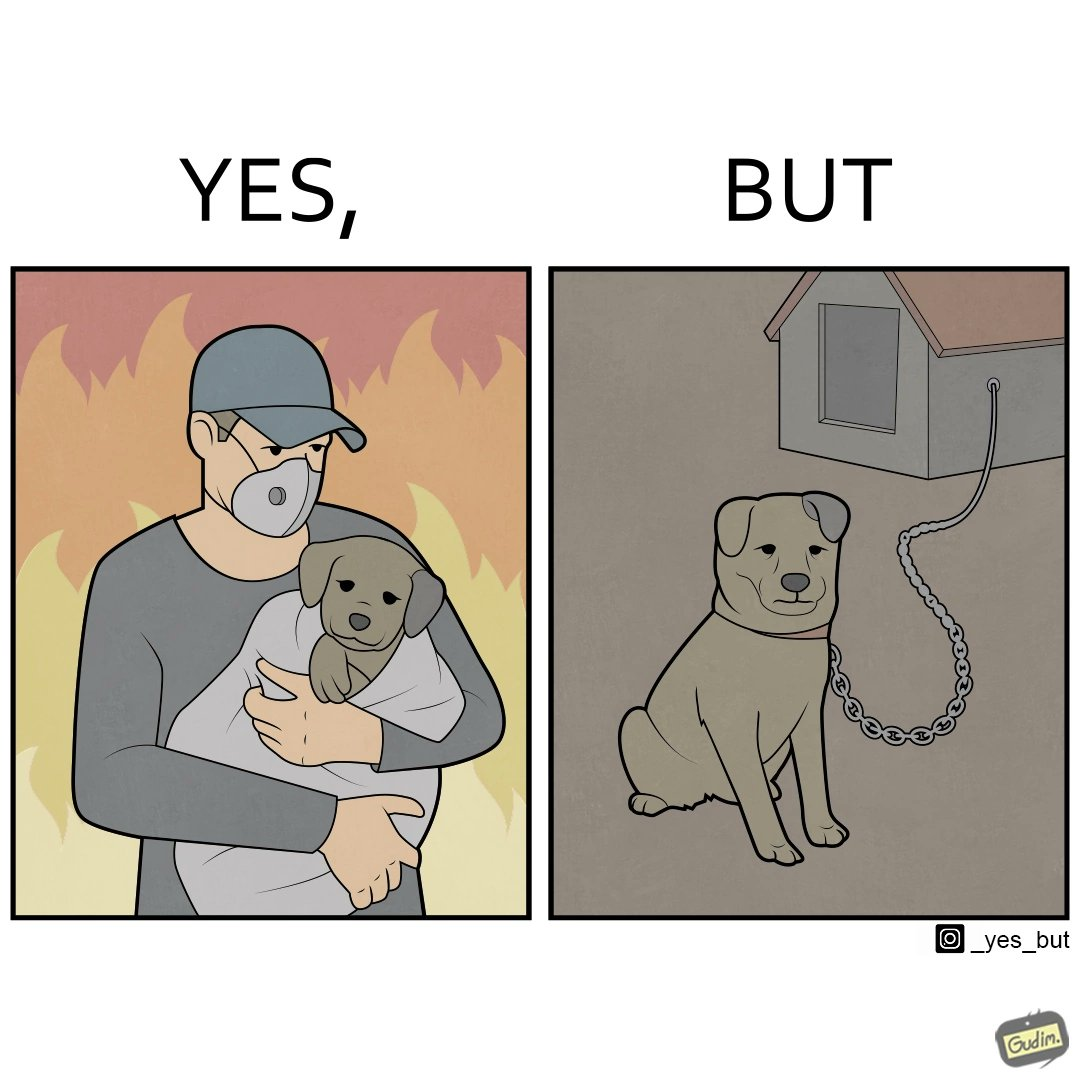What do you see in each half of this image? In the left part of the image: a man, wearing mask, protecting a puppy from fire, in the background, by covering it in a sheet of cloth In the right part of the image: a puppy chained to a kennel 